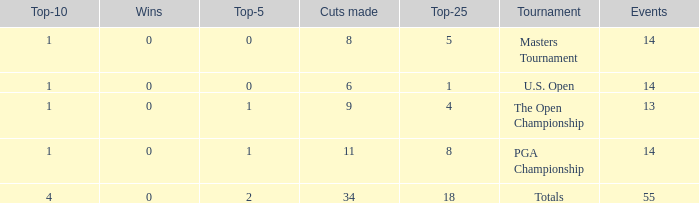What is the sum of wins when events is 13 and top-5 is less than 1? None. 